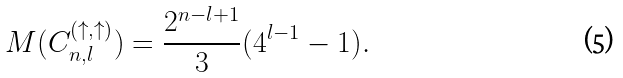<formula> <loc_0><loc_0><loc_500><loc_500>M ( C _ { n , l } ^ { ( \uparrow , \uparrow ) } ) = \frac { 2 ^ { n - l + 1 } } { 3 } ( 4 ^ { l - 1 } - 1 ) .</formula> 